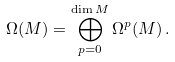Convert formula to latex. <formula><loc_0><loc_0><loc_500><loc_500>\Omega ( M ) = \bigoplus _ { p = 0 } ^ { \dim M } \Omega ^ { p } ( M ) \, .</formula> 